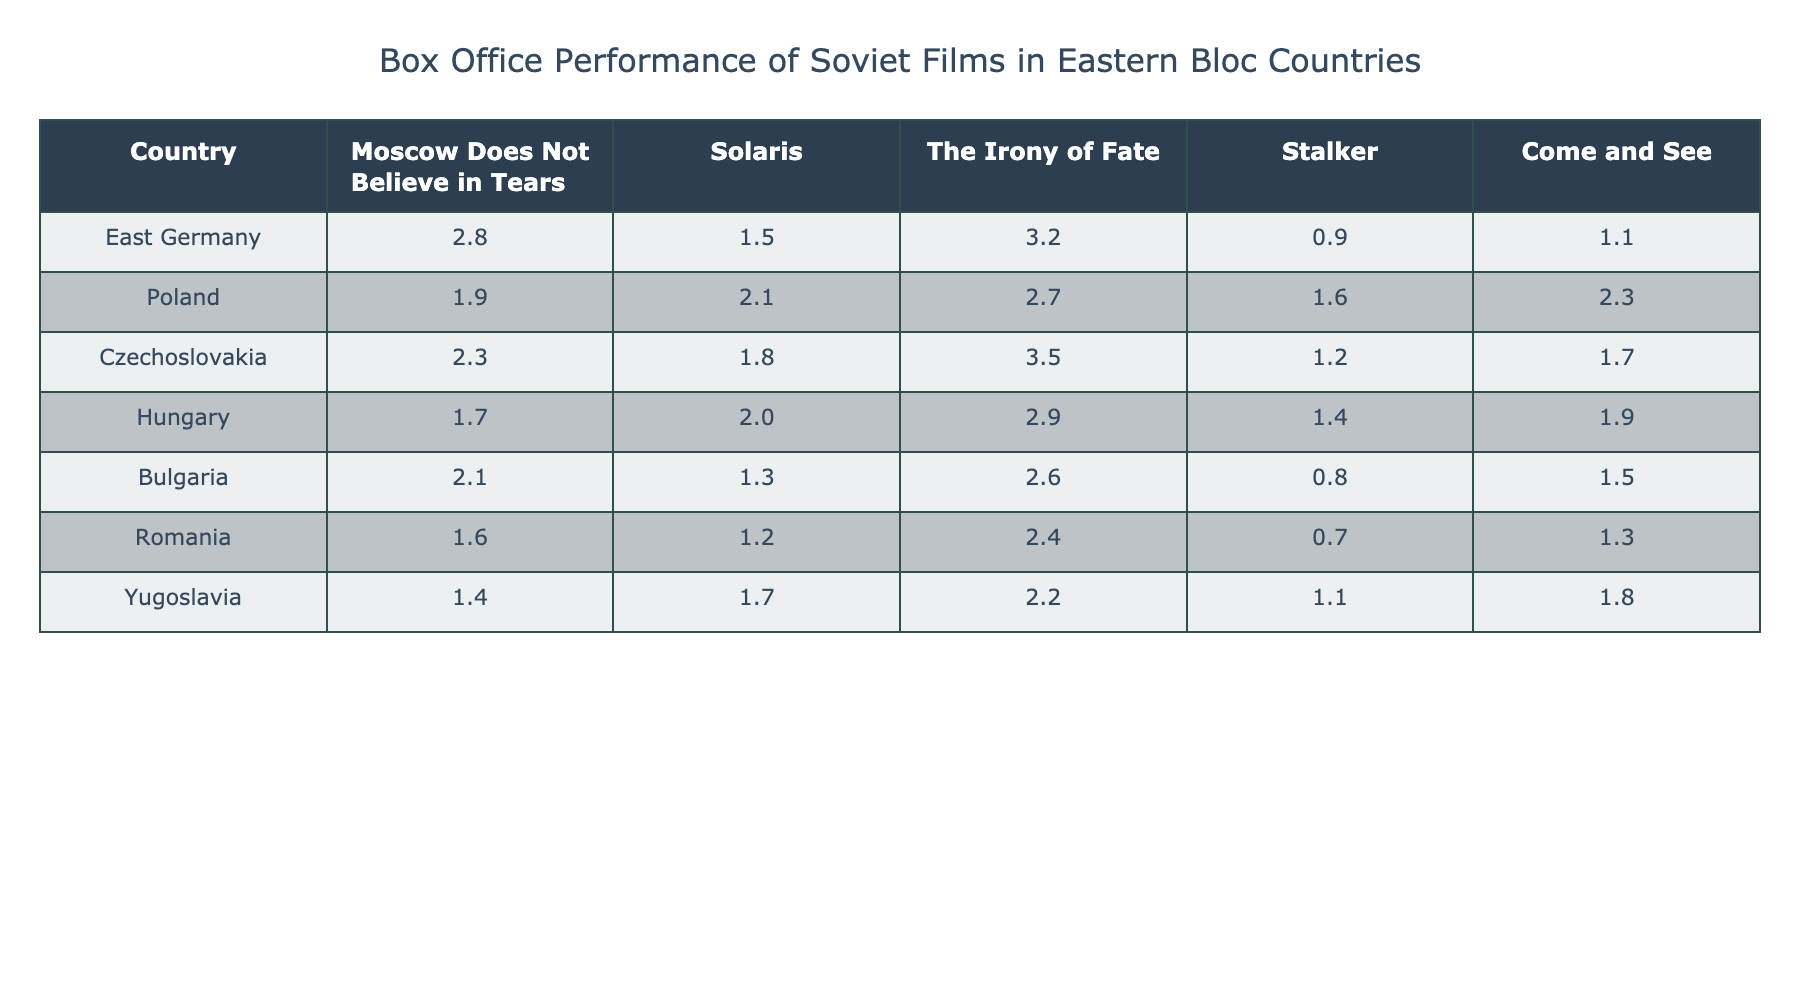What is the highest box office performance film in East Germany? The film with the highest box office performance in East Germany is "The Irony of Fate" with a value of 3.2.
Answer: 3.2 Which country had the lowest box office performance for "Come and See"? Romania had the lowest box office performance for "Come and See" with a value of 1.3.
Answer: 1.3 What is the average box office performance of "Solaris" across all listed countries? To find the average, sum the box office values for "Solaris" (1.5 + 2.1 + 1.8 + 2.0 + 1.3 + 1.2 + 1.7) = 12.7, then divide by the number of countries (7), giving an average of 12.7 / 7 ≈ 1.81.
Answer: 1.81 Did Hungary have a better performance for "Moscow Does Not Believe in Tears" compared to Bulgaria? Hungary's performance for "Moscow Does Not Believe in Tears" is 1.7, while Bulgaria's is 2.1, making Bulgaria's performance better.
Answer: No How much more did "The Irony of Fate" earn in Czechoslovakia compared to the earnings in Romania? The earnings in Czechoslovakia for "The Irony of Fate" is 3.5, while in Romania it is 2.4. The difference is 3.5 - 2.4 = 1.1.
Answer: 1.1 What is the total box office performance of all films in Poland? The total box office performance for Poland is calculated by summing the values: (1.9 + 2.1 + 2.7 + 1.6 + 2.3) = 10.6.
Answer: 10.6 Which film had the highest total box office performance across all countries, and what was the total? By adding the box office values for each film, "The Irony of Fate" has the highest total: 3.2 (East Germany) + 2.7 (Poland) + 3.5 (Czechoslovakia) + 2.9 (Hungary) + 2.6 (Bulgaria) + 2.4 (Romania) + 2.2 (Yugoslavia) = 19.5.
Answer: 19.5 Is it true that all films performed better in Czechoslovakia than in Romania? Comparing Czechoslovakia and Romania for each film, "Moscow Does Not Believe in Tears" (2.3 vs 1.6), "Solaris" (1.8 vs 1.2), "The Irony of Fate" (3.5 vs 2.4), "Stalker" (1.2 vs 0.7), and "Come and See" (1.7 vs 1.3) show that all films performed better in Czechoslovakia.
Answer: Yes What is the performance difference between "Stalker" in Hungary and "Come and See" in Bulgaria? The performance of "Stalker" in Hungary is 1.4 and for "Come and See" in Bulgaria is 1.5. The difference is 1.5 - 1.4 = 0.1.
Answer: 0.1 Can you identify if any film performed equally in at least two countries? By examining the films' performances across countries, we can see that both "Solaris" and "Stalker" have the same performance (1.7) in Yugoslavia.
Answer: Yes 